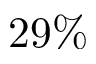<formula> <loc_0><loc_0><loc_500><loc_500>2 9 \%</formula> 